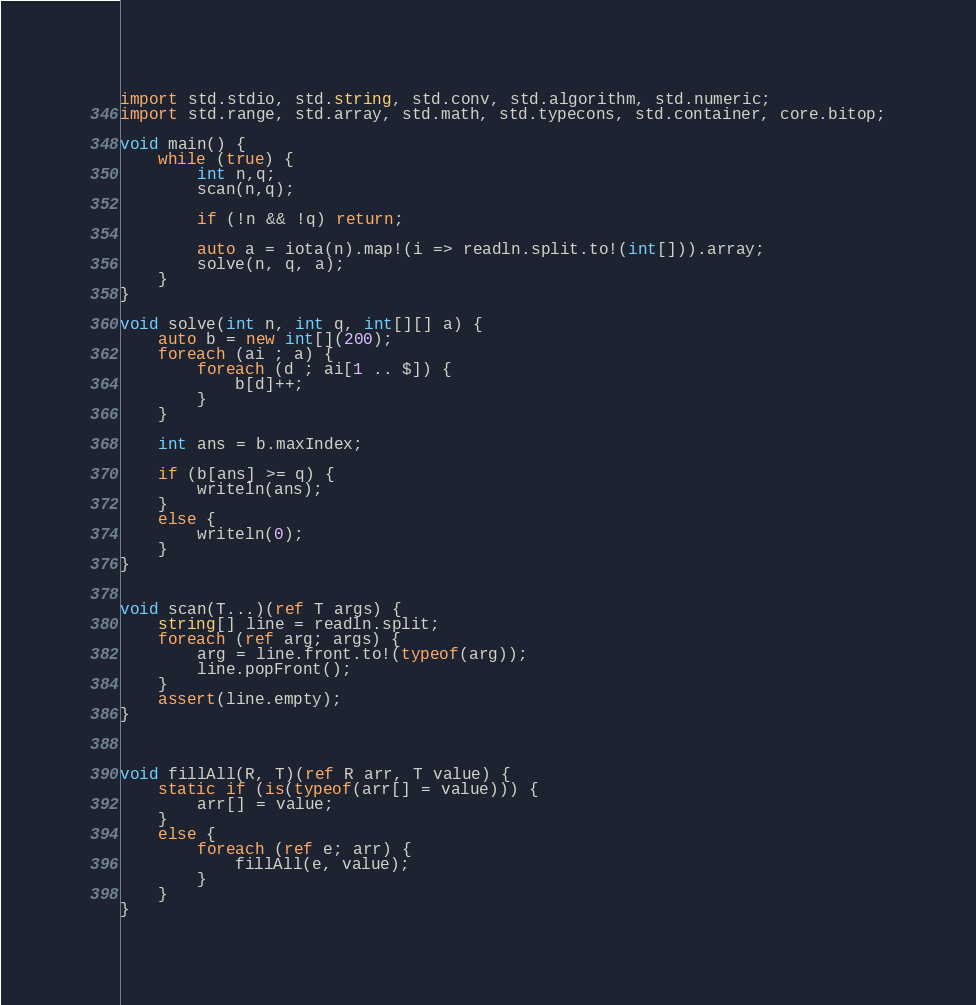Convert code to text. <code><loc_0><loc_0><loc_500><loc_500><_D_>import std.stdio, std.string, std.conv, std.algorithm, std.numeric;
import std.range, std.array, std.math, std.typecons, std.container, core.bitop;

void main() {
    while (true) {
        int n,q;
        scan(n,q);

        if (!n && !q) return;

        auto a = iota(n).map!(i => readln.split.to!(int[])).array;
        solve(n, q, a);
    }
}

void solve(int n, int q, int[][] a) {
    auto b = new int[](200);
    foreach (ai ; a) {
        foreach (d ; ai[1 .. $]) {
            b[d]++;
        }
    }

    int ans = b.maxIndex;

    if (b[ans] >= q) {
        writeln(ans);
    }
    else {
        writeln(0);
    }
}


void scan(T...)(ref T args) {
    string[] line = readln.split;
    foreach (ref arg; args) {
        arg = line.front.to!(typeof(arg));
        line.popFront();
    }
    assert(line.empty);
}



void fillAll(R, T)(ref R arr, T value) {
    static if (is(typeof(arr[] = value))) {
        arr[] = value;
    }
    else {
        foreach (ref e; arr) {
            fillAll(e, value);
        }
    }
}</code> 